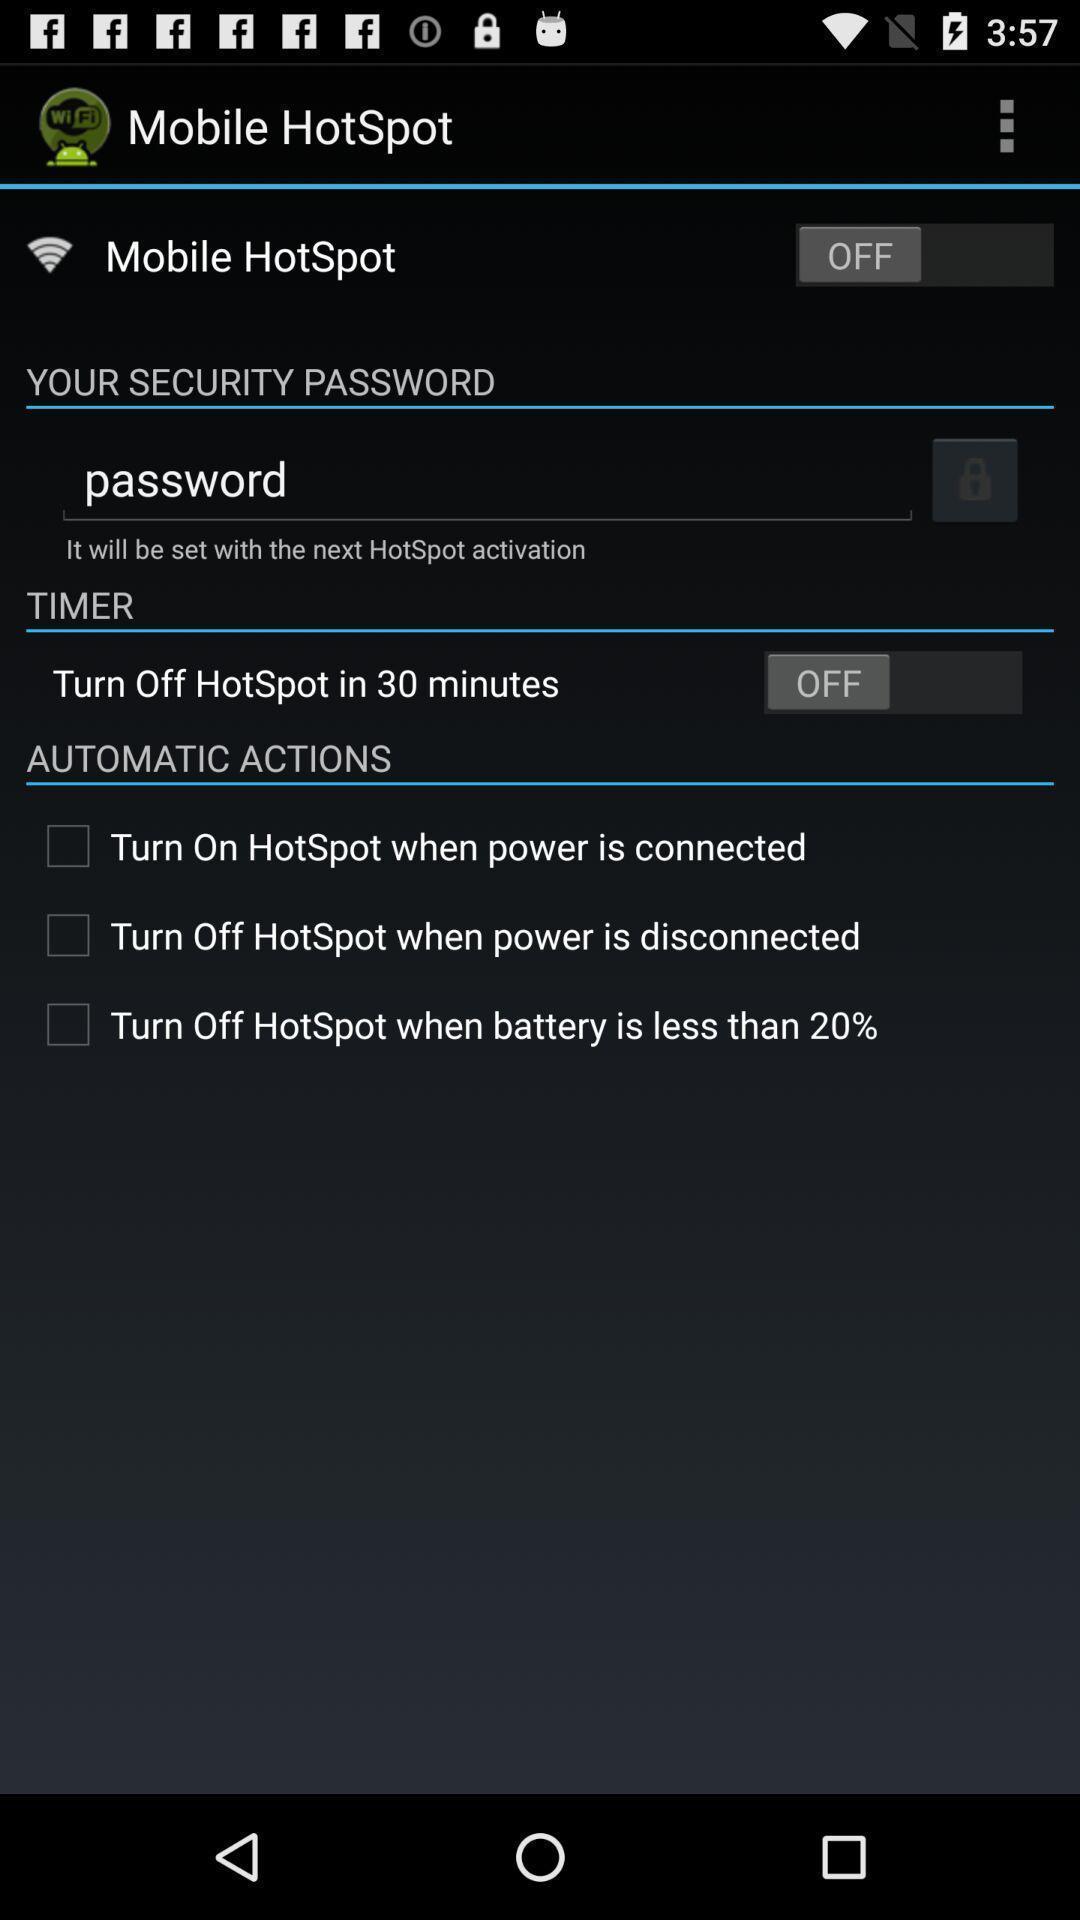Describe this image in words. Page shows mobile hotspot with some information. 